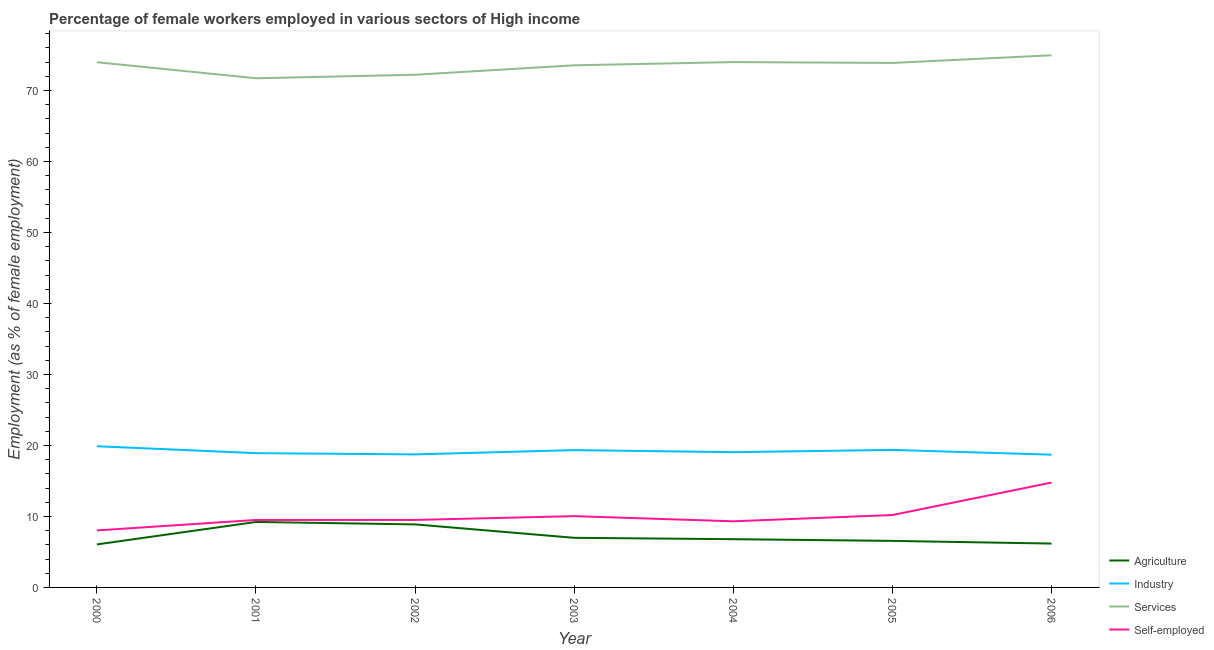Does the line corresponding to percentage of female workers in services intersect with the line corresponding to percentage of female workers in agriculture?
Provide a succinct answer. No. What is the percentage of female workers in services in 2004?
Your response must be concise. 74. Across all years, what is the maximum percentage of female workers in services?
Ensure brevity in your answer.  74.95. Across all years, what is the minimum percentage of self employed female workers?
Offer a terse response. 8.03. In which year was the percentage of self employed female workers maximum?
Provide a succinct answer. 2006. What is the total percentage of female workers in industry in the graph?
Ensure brevity in your answer.  134. What is the difference between the percentage of self employed female workers in 2001 and that in 2003?
Provide a short and direct response. -0.54. What is the difference between the percentage of female workers in agriculture in 2006 and the percentage of female workers in services in 2003?
Keep it short and to the point. -67.36. What is the average percentage of self employed female workers per year?
Your response must be concise. 10.19. In the year 2005, what is the difference between the percentage of female workers in agriculture and percentage of female workers in services?
Offer a terse response. -67.32. What is the ratio of the percentage of female workers in services in 2001 to that in 2004?
Provide a succinct answer. 0.97. What is the difference between the highest and the second highest percentage of self employed female workers?
Your answer should be compact. 4.57. What is the difference between the highest and the lowest percentage of female workers in services?
Make the answer very short. 3.24. In how many years, is the percentage of female workers in industry greater than the average percentage of female workers in industry taken over all years?
Your response must be concise. 3. Is the sum of the percentage of female workers in industry in 2002 and 2004 greater than the maximum percentage of female workers in services across all years?
Your answer should be very brief. No. Is it the case that in every year, the sum of the percentage of self employed female workers and percentage of female workers in industry is greater than the sum of percentage of female workers in agriculture and percentage of female workers in services?
Make the answer very short. No. Is it the case that in every year, the sum of the percentage of female workers in agriculture and percentage of female workers in industry is greater than the percentage of female workers in services?
Offer a very short reply. No. Is the percentage of self employed female workers strictly greater than the percentage of female workers in industry over the years?
Your response must be concise. No. Is the percentage of female workers in agriculture strictly less than the percentage of female workers in industry over the years?
Provide a short and direct response. Yes. What is the difference between two consecutive major ticks on the Y-axis?
Keep it short and to the point. 10. Does the graph contain any zero values?
Offer a terse response. No. Where does the legend appear in the graph?
Provide a short and direct response. Bottom right. What is the title of the graph?
Ensure brevity in your answer.  Percentage of female workers employed in various sectors of High income. Does "Corruption" appear as one of the legend labels in the graph?
Give a very brief answer. No. What is the label or title of the X-axis?
Offer a very short reply. Year. What is the label or title of the Y-axis?
Provide a short and direct response. Employment (as % of female employment). What is the Employment (as % of female employment) of Agriculture in 2000?
Ensure brevity in your answer.  6.06. What is the Employment (as % of female employment) of Industry in 2000?
Provide a succinct answer. 19.89. What is the Employment (as % of female employment) of Services in 2000?
Your response must be concise. 73.98. What is the Employment (as % of female employment) in Self-employed in 2000?
Your response must be concise. 8.03. What is the Employment (as % of female employment) of Agriculture in 2001?
Give a very brief answer. 9.22. What is the Employment (as % of female employment) of Industry in 2001?
Offer a very short reply. 18.91. What is the Employment (as % of female employment) of Services in 2001?
Your response must be concise. 71.72. What is the Employment (as % of female employment) of Self-employed in 2001?
Give a very brief answer. 9.5. What is the Employment (as % of female employment) of Agriculture in 2002?
Keep it short and to the point. 8.88. What is the Employment (as % of female employment) of Industry in 2002?
Offer a very short reply. 18.74. What is the Employment (as % of female employment) of Services in 2002?
Your response must be concise. 72.21. What is the Employment (as % of female employment) of Self-employed in 2002?
Make the answer very short. 9.51. What is the Employment (as % of female employment) of Agriculture in 2003?
Your answer should be compact. 6.99. What is the Employment (as % of female employment) in Industry in 2003?
Your response must be concise. 19.34. What is the Employment (as % of female employment) of Services in 2003?
Give a very brief answer. 73.54. What is the Employment (as % of female employment) in Self-employed in 2003?
Provide a succinct answer. 10.04. What is the Employment (as % of female employment) in Agriculture in 2004?
Your response must be concise. 6.8. What is the Employment (as % of female employment) of Industry in 2004?
Your response must be concise. 19.05. What is the Employment (as % of female employment) in Services in 2004?
Make the answer very short. 74. What is the Employment (as % of female employment) of Self-employed in 2004?
Offer a very short reply. 9.31. What is the Employment (as % of female employment) of Agriculture in 2005?
Ensure brevity in your answer.  6.55. What is the Employment (as % of female employment) of Industry in 2005?
Offer a terse response. 19.37. What is the Employment (as % of female employment) of Services in 2005?
Your answer should be compact. 73.87. What is the Employment (as % of female employment) of Self-employed in 2005?
Your answer should be compact. 10.2. What is the Employment (as % of female employment) in Agriculture in 2006?
Make the answer very short. 6.18. What is the Employment (as % of female employment) of Industry in 2006?
Provide a succinct answer. 18.7. What is the Employment (as % of female employment) of Services in 2006?
Provide a short and direct response. 74.95. What is the Employment (as % of female employment) of Self-employed in 2006?
Offer a very short reply. 14.77. Across all years, what is the maximum Employment (as % of female employment) of Agriculture?
Keep it short and to the point. 9.22. Across all years, what is the maximum Employment (as % of female employment) of Industry?
Provide a succinct answer. 19.89. Across all years, what is the maximum Employment (as % of female employment) in Services?
Keep it short and to the point. 74.95. Across all years, what is the maximum Employment (as % of female employment) of Self-employed?
Your answer should be very brief. 14.77. Across all years, what is the minimum Employment (as % of female employment) of Agriculture?
Give a very brief answer. 6.06. Across all years, what is the minimum Employment (as % of female employment) of Industry?
Provide a succinct answer. 18.7. Across all years, what is the minimum Employment (as % of female employment) in Services?
Your response must be concise. 71.72. Across all years, what is the minimum Employment (as % of female employment) of Self-employed?
Offer a very short reply. 8.03. What is the total Employment (as % of female employment) in Agriculture in the graph?
Give a very brief answer. 50.67. What is the total Employment (as % of female employment) in Industry in the graph?
Offer a terse response. 134. What is the total Employment (as % of female employment) in Services in the graph?
Offer a terse response. 514.27. What is the total Employment (as % of female employment) in Self-employed in the graph?
Your answer should be very brief. 71.36. What is the difference between the Employment (as % of female employment) in Agriculture in 2000 and that in 2001?
Your answer should be compact. -3.16. What is the difference between the Employment (as % of female employment) of Industry in 2000 and that in 2001?
Offer a terse response. 0.97. What is the difference between the Employment (as % of female employment) of Services in 2000 and that in 2001?
Keep it short and to the point. 2.26. What is the difference between the Employment (as % of female employment) in Self-employed in 2000 and that in 2001?
Your answer should be compact. -1.48. What is the difference between the Employment (as % of female employment) in Agriculture in 2000 and that in 2002?
Provide a short and direct response. -2.82. What is the difference between the Employment (as % of female employment) in Industry in 2000 and that in 2002?
Give a very brief answer. 1.15. What is the difference between the Employment (as % of female employment) of Services in 2000 and that in 2002?
Make the answer very short. 1.77. What is the difference between the Employment (as % of female employment) of Self-employed in 2000 and that in 2002?
Offer a terse response. -1.48. What is the difference between the Employment (as % of female employment) of Agriculture in 2000 and that in 2003?
Your response must be concise. -0.93. What is the difference between the Employment (as % of female employment) in Industry in 2000 and that in 2003?
Make the answer very short. 0.55. What is the difference between the Employment (as % of female employment) in Services in 2000 and that in 2003?
Make the answer very short. 0.44. What is the difference between the Employment (as % of female employment) of Self-employed in 2000 and that in 2003?
Provide a short and direct response. -2.02. What is the difference between the Employment (as % of female employment) in Agriculture in 2000 and that in 2004?
Your answer should be compact. -0.74. What is the difference between the Employment (as % of female employment) of Industry in 2000 and that in 2004?
Your answer should be compact. 0.83. What is the difference between the Employment (as % of female employment) of Services in 2000 and that in 2004?
Your answer should be compact. -0.02. What is the difference between the Employment (as % of female employment) of Self-employed in 2000 and that in 2004?
Provide a short and direct response. -1.29. What is the difference between the Employment (as % of female employment) of Agriculture in 2000 and that in 2005?
Ensure brevity in your answer.  -0.5. What is the difference between the Employment (as % of female employment) of Industry in 2000 and that in 2005?
Offer a very short reply. 0.52. What is the difference between the Employment (as % of female employment) of Services in 2000 and that in 2005?
Provide a short and direct response. 0.1. What is the difference between the Employment (as % of female employment) in Self-employed in 2000 and that in 2005?
Make the answer very short. -2.17. What is the difference between the Employment (as % of female employment) of Agriculture in 2000 and that in 2006?
Offer a terse response. -0.12. What is the difference between the Employment (as % of female employment) of Industry in 2000 and that in 2006?
Offer a very short reply. 1.19. What is the difference between the Employment (as % of female employment) of Services in 2000 and that in 2006?
Offer a very short reply. -0.97. What is the difference between the Employment (as % of female employment) in Self-employed in 2000 and that in 2006?
Provide a short and direct response. -6.75. What is the difference between the Employment (as % of female employment) in Agriculture in 2001 and that in 2002?
Your answer should be very brief. 0.34. What is the difference between the Employment (as % of female employment) in Industry in 2001 and that in 2002?
Your answer should be compact. 0.18. What is the difference between the Employment (as % of female employment) of Services in 2001 and that in 2002?
Offer a very short reply. -0.49. What is the difference between the Employment (as % of female employment) in Self-employed in 2001 and that in 2002?
Ensure brevity in your answer.  -0. What is the difference between the Employment (as % of female employment) in Agriculture in 2001 and that in 2003?
Your response must be concise. 2.23. What is the difference between the Employment (as % of female employment) of Industry in 2001 and that in 2003?
Your response must be concise. -0.43. What is the difference between the Employment (as % of female employment) in Services in 2001 and that in 2003?
Provide a succinct answer. -1.82. What is the difference between the Employment (as % of female employment) of Self-employed in 2001 and that in 2003?
Ensure brevity in your answer.  -0.54. What is the difference between the Employment (as % of female employment) of Agriculture in 2001 and that in 2004?
Keep it short and to the point. 2.43. What is the difference between the Employment (as % of female employment) of Industry in 2001 and that in 2004?
Offer a very short reply. -0.14. What is the difference between the Employment (as % of female employment) in Services in 2001 and that in 2004?
Offer a terse response. -2.28. What is the difference between the Employment (as % of female employment) of Self-employed in 2001 and that in 2004?
Provide a short and direct response. 0.19. What is the difference between the Employment (as % of female employment) in Agriculture in 2001 and that in 2005?
Offer a very short reply. 2.67. What is the difference between the Employment (as % of female employment) of Industry in 2001 and that in 2005?
Provide a succinct answer. -0.46. What is the difference between the Employment (as % of female employment) of Services in 2001 and that in 2005?
Provide a short and direct response. -2.16. What is the difference between the Employment (as % of female employment) of Self-employed in 2001 and that in 2005?
Your response must be concise. -0.69. What is the difference between the Employment (as % of female employment) of Agriculture in 2001 and that in 2006?
Provide a succinct answer. 3.04. What is the difference between the Employment (as % of female employment) in Industry in 2001 and that in 2006?
Provide a short and direct response. 0.22. What is the difference between the Employment (as % of female employment) of Services in 2001 and that in 2006?
Ensure brevity in your answer.  -3.24. What is the difference between the Employment (as % of female employment) of Self-employed in 2001 and that in 2006?
Offer a very short reply. -5.27. What is the difference between the Employment (as % of female employment) in Agriculture in 2002 and that in 2003?
Ensure brevity in your answer.  1.89. What is the difference between the Employment (as % of female employment) of Industry in 2002 and that in 2003?
Provide a short and direct response. -0.6. What is the difference between the Employment (as % of female employment) in Services in 2002 and that in 2003?
Your answer should be compact. -1.33. What is the difference between the Employment (as % of female employment) of Self-employed in 2002 and that in 2003?
Provide a short and direct response. -0.54. What is the difference between the Employment (as % of female employment) in Agriculture in 2002 and that in 2004?
Keep it short and to the point. 2.08. What is the difference between the Employment (as % of female employment) in Industry in 2002 and that in 2004?
Offer a terse response. -0.31. What is the difference between the Employment (as % of female employment) in Services in 2002 and that in 2004?
Give a very brief answer. -1.79. What is the difference between the Employment (as % of female employment) of Self-employed in 2002 and that in 2004?
Your answer should be compact. 0.19. What is the difference between the Employment (as % of female employment) in Agriculture in 2002 and that in 2005?
Make the answer very short. 2.32. What is the difference between the Employment (as % of female employment) in Industry in 2002 and that in 2005?
Offer a very short reply. -0.63. What is the difference between the Employment (as % of female employment) in Services in 2002 and that in 2005?
Your answer should be compact. -1.67. What is the difference between the Employment (as % of female employment) in Self-employed in 2002 and that in 2005?
Your answer should be compact. -0.69. What is the difference between the Employment (as % of female employment) in Agriculture in 2002 and that in 2006?
Your answer should be very brief. 2.7. What is the difference between the Employment (as % of female employment) in Industry in 2002 and that in 2006?
Keep it short and to the point. 0.04. What is the difference between the Employment (as % of female employment) in Services in 2002 and that in 2006?
Keep it short and to the point. -2.74. What is the difference between the Employment (as % of female employment) in Self-employed in 2002 and that in 2006?
Ensure brevity in your answer.  -5.26. What is the difference between the Employment (as % of female employment) of Agriculture in 2003 and that in 2004?
Make the answer very short. 0.19. What is the difference between the Employment (as % of female employment) in Industry in 2003 and that in 2004?
Your answer should be very brief. 0.29. What is the difference between the Employment (as % of female employment) in Services in 2003 and that in 2004?
Provide a short and direct response. -0.46. What is the difference between the Employment (as % of female employment) in Self-employed in 2003 and that in 2004?
Your answer should be compact. 0.73. What is the difference between the Employment (as % of female employment) of Agriculture in 2003 and that in 2005?
Make the answer very short. 0.43. What is the difference between the Employment (as % of female employment) of Industry in 2003 and that in 2005?
Offer a terse response. -0.03. What is the difference between the Employment (as % of female employment) in Services in 2003 and that in 2005?
Provide a succinct answer. -0.33. What is the difference between the Employment (as % of female employment) of Self-employed in 2003 and that in 2005?
Make the answer very short. -0.16. What is the difference between the Employment (as % of female employment) of Agriculture in 2003 and that in 2006?
Make the answer very short. 0.81. What is the difference between the Employment (as % of female employment) of Industry in 2003 and that in 2006?
Offer a terse response. 0.64. What is the difference between the Employment (as % of female employment) in Services in 2003 and that in 2006?
Keep it short and to the point. -1.41. What is the difference between the Employment (as % of female employment) of Self-employed in 2003 and that in 2006?
Ensure brevity in your answer.  -4.73. What is the difference between the Employment (as % of female employment) in Agriculture in 2004 and that in 2005?
Your answer should be very brief. 0.24. What is the difference between the Employment (as % of female employment) in Industry in 2004 and that in 2005?
Offer a very short reply. -0.32. What is the difference between the Employment (as % of female employment) of Services in 2004 and that in 2005?
Give a very brief answer. 0.12. What is the difference between the Employment (as % of female employment) in Self-employed in 2004 and that in 2005?
Offer a terse response. -0.88. What is the difference between the Employment (as % of female employment) of Agriculture in 2004 and that in 2006?
Provide a short and direct response. 0.62. What is the difference between the Employment (as % of female employment) of Industry in 2004 and that in 2006?
Ensure brevity in your answer.  0.35. What is the difference between the Employment (as % of female employment) of Services in 2004 and that in 2006?
Ensure brevity in your answer.  -0.96. What is the difference between the Employment (as % of female employment) in Self-employed in 2004 and that in 2006?
Your answer should be compact. -5.46. What is the difference between the Employment (as % of female employment) in Agriculture in 2005 and that in 2006?
Ensure brevity in your answer.  0.38. What is the difference between the Employment (as % of female employment) of Industry in 2005 and that in 2006?
Your answer should be compact. 0.67. What is the difference between the Employment (as % of female employment) in Services in 2005 and that in 2006?
Offer a terse response. -1.08. What is the difference between the Employment (as % of female employment) of Self-employed in 2005 and that in 2006?
Keep it short and to the point. -4.57. What is the difference between the Employment (as % of female employment) of Agriculture in 2000 and the Employment (as % of female employment) of Industry in 2001?
Your answer should be compact. -12.86. What is the difference between the Employment (as % of female employment) of Agriculture in 2000 and the Employment (as % of female employment) of Services in 2001?
Provide a succinct answer. -65.66. What is the difference between the Employment (as % of female employment) of Agriculture in 2000 and the Employment (as % of female employment) of Self-employed in 2001?
Provide a succinct answer. -3.45. What is the difference between the Employment (as % of female employment) of Industry in 2000 and the Employment (as % of female employment) of Services in 2001?
Provide a short and direct response. -51.83. What is the difference between the Employment (as % of female employment) of Industry in 2000 and the Employment (as % of female employment) of Self-employed in 2001?
Provide a succinct answer. 10.38. What is the difference between the Employment (as % of female employment) of Services in 2000 and the Employment (as % of female employment) of Self-employed in 2001?
Ensure brevity in your answer.  64.48. What is the difference between the Employment (as % of female employment) of Agriculture in 2000 and the Employment (as % of female employment) of Industry in 2002?
Give a very brief answer. -12.68. What is the difference between the Employment (as % of female employment) of Agriculture in 2000 and the Employment (as % of female employment) of Services in 2002?
Ensure brevity in your answer.  -66.15. What is the difference between the Employment (as % of female employment) in Agriculture in 2000 and the Employment (as % of female employment) in Self-employed in 2002?
Offer a very short reply. -3.45. What is the difference between the Employment (as % of female employment) of Industry in 2000 and the Employment (as % of female employment) of Services in 2002?
Give a very brief answer. -52.32. What is the difference between the Employment (as % of female employment) in Industry in 2000 and the Employment (as % of female employment) in Self-employed in 2002?
Keep it short and to the point. 10.38. What is the difference between the Employment (as % of female employment) in Services in 2000 and the Employment (as % of female employment) in Self-employed in 2002?
Your response must be concise. 64.47. What is the difference between the Employment (as % of female employment) of Agriculture in 2000 and the Employment (as % of female employment) of Industry in 2003?
Make the answer very short. -13.28. What is the difference between the Employment (as % of female employment) of Agriculture in 2000 and the Employment (as % of female employment) of Services in 2003?
Your response must be concise. -67.48. What is the difference between the Employment (as % of female employment) in Agriculture in 2000 and the Employment (as % of female employment) in Self-employed in 2003?
Offer a terse response. -3.98. What is the difference between the Employment (as % of female employment) of Industry in 2000 and the Employment (as % of female employment) of Services in 2003?
Ensure brevity in your answer.  -53.65. What is the difference between the Employment (as % of female employment) of Industry in 2000 and the Employment (as % of female employment) of Self-employed in 2003?
Offer a very short reply. 9.85. What is the difference between the Employment (as % of female employment) in Services in 2000 and the Employment (as % of female employment) in Self-employed in 2003?
Your response must be concise. 63.94. What is the difference between the Employment (as % of female employment) of Agriculture in 2000 and the Employment (as % of female employment) of Industry in 2004?
Offer a very short reply. -12.99. What is the difference between the Employment (as % of female employment) in Agriculture in 2000 and the Employment (as % of female employment) in Services in 2004?
Ensure brevity in your answer.  -67.94. What is the difference between the Employment (as % of female employment) in Agriculture in 2000 and the Employment (as % of female employment) in Self-employed in 2004?
Your answer should be very brief. -3.26. What is the difference between the Employment (as % of female employment) in Industry in 2000 and the Employment (as % of female employment) in Services in 2004?
Ensure brevity in your answer.  -54.11. What is the difference between the Employment (as % of female employment) in Industry in 2000 and the Employment (as % of female employment) in Self-employed in 2004?
Your answer should be very brief. 10.57. What is the difference between the Employment (as % of female employment) in Services in 2000 and the Employment (as % of female employment) in Self-employed in 2004?
Your response must be concise. 64.66. What is the difference between the Employment (as % of female employment) in Agriculture in 2000 and the Employment (as % of female employment) in Industry in 2005?
Your response must be concise. -13.31. What is the difference between the Employment (as % of female employment) of Agriculture in 2000 and the Employment (as % of female employment) of Services in 2005?
Provide a short and direct response. -67.82. What is the difference between the Employment (as % of female employment) of Agriculture in 2000 and the Employment (as % of female employment) of Self-employed in 2005?
Offer a terse response. -4.14. What is the difference between the Employment (as % of female employment) in Industry in 2000 and the Employment (as % of female employment) in Services in 2005?
Provide a succinct answer. -53.99. What is the difference between the Employment (as % of female employment) of Industry in 2000 and the Employment (as % of female employment) of Self-employed in 2005?
Offer a very short reply. 9.69. What is the difference between the Employment (as % of female employment) in Services in 2000 and the Employment (as % of female employment) in Self-employed in 2005?
Make the answer very short. 63.78. What is the difference between the Employment (as % of female employment) in Agriculture in 2000 and the Employment (as % of female employment) in Industry in 2006?
Make the answer very short. -12.64. What is the difference between the Employment (as % of female employment) in Agriculture in 2000 and the Employment (as % of female employment) in Services in 2006?
Ensure brevity in your answer.  -68.9. What is the difference between the Employment (as % of female employment) of Agriculture in 2000 and the Employment (as % of female employment) of Self-employed in 2006?
Provide a short and direct response. -8.71. What is the difference between the Employment (as % of female employment) in Industry in 2000 and the Employment (as % of female employment) in Services in 2006?
Offer a very short reply. -55.07. What is the difference between the Employment (as % of female employment) in Industry in 2000 and the Employment (as % of female employment) in Self-employed in 2006?
Ensure brevity in your answer.  5.12. What is the difference between the Employment (as % of female employment) in Services in 2000 and the Employment (as % of female employment) in Self-employed in 2006?
Provide a short and direct response. 59.21. What is the difference between the Employment (as % of female employment) in Agriculture in 2001 and the Employment (as % of female employment) in Industry in 2002?
Keep it short and to the point. -9.52. What is the difference between the Employment (as % of female employment) in Agriculture in 2001 and the Employment (as % of female employment) in Services in 2002?
Provide a short and direct response. -62.99. What is the difference between the Employment (as % of female employment) in Agriculture in 2001 and the Employment (as % of female employment) in Self-employed in 2002?
Ensure brevity in your answer.  -0.29. What is the difference between the Employment (as % of female employment) in Industry in 2001 and the Employment (as % of female employment) in Services in 2002?
Make the answer very short. -53.29. What is the difference between the Employment (as % of female employment) in Industry in 2001 and the Employment (as % of female employment) in Self-employed in 2002?
Keep it short and to the point. 9.41. What is the difference between the Employment (as % of female employment) of Services in 2001 and the Employment (as % of female employment) of Self-employed in 2002?
Ensure brevity in your answer.  62.21. What is the difference between the Employment (as % of female employment) in Agriculture in 2001 and the Employment (as % of female employment) in Industry in 2003?
Make the answer very short. -10.12. What is the difference between the Employment (as % of female employment) of Agriculture in 2001 and the Employment (as % of female employment) of Services in 2003?
Make the answer very short. -64.32. What is the difference between the Employment (as % of female employment) of Agriculture in 2001 and the Employment (as % of female employment) of Self-employed in 2003?
Make the answer very short. -0.82. What is the difference between the Employment (as % of female employment) in Industry in 2001 and the Employment (as % of female employment) in Services in 2003?
Give a very brief answer. -54.63. What is the difference between the Employment (as % of female employment) of Industry in 2001 and the Employment (as % of female employment) of Self-employed in 2003?
Make the answer very short. 8.87. What is the difference between the Employment (as % of female employment) in Services in 2001 and the Employment (as % of female employment) in Self-employed in 2003?
Your answer should be very brief. 61.68. What is the difference between the Employment (as % of female employment) of Agriculture in 2001 and the Employment (as % of female employment) of Industry in 2004?
Ensure brevity in your answer.  -9.83. What is the difference between the Employment (as % of female employment) of Agriculture in 2001 and the Employment (as % of female employment) of Services in 2004?
Ensure brevity in your answer.  -64.77. What is the difference between the Employment (as % of female employment) in Agriculture in 2001 and the Employment (as % of female employment) in Self-employed in 2004?
Keep it short and to the point. -0.09. What is the difference between the Employment (as % of female employment) in Industry in 2001 and the Employment (as % of female employment) in Services in 2004?
Provide a short and direct response. -55.08. What is the difference between the Employment (as % of female employment) in Industry in 2001 and the Employment (as % of female employment) in Self-employed in 2004?
Give a very brief answer. 9.6. What is the difference between the Employment (as % of female employment) in Services in 2001 and the Employment (as % of female employment) in Self-employed in 2004?
Offer a very short reply. 62.4. What is the difference between the Employment (as % of female employment) of Agriculture in 2001 and the Employment (as % of female employment) of Industry in 2005?
Offer a terse response. -10.15. What is the difference between the Employment (as % of female employment) in Agriculture in 2001 and the Employment (as % of female employment) in Services in 2005?
Your response must be concise. -64.65. What is the difference between the Employment (as % of female employment) in Agriculture in 2001 and the Employment (as % of female employment) in Self-employed in 2005?
Offer a terse response. -0.98. What is the difference between the Employment (as % of female employment) in Industry in 2001 and the Employment (as % of female employment) in Services in 2005?
Provide a short and direct response. -54.96. What is the difference between the Employment (as % of female employment) in Industry in 2001 and the Employment (as % of female employment) in Self-employed in 2005?
Ensure brevity in your answer.  8.72. What is the difference between the Employment (as % of female employment) of Services in 2001 and the Employment (as % of female employment) of Self-employed in 2005?
Make the answer very short. 61.52. What is the difference between the Employment (as % of female employment) in Agriculture in 2001 and the Employment (as % of female employment) in Industry in 2006?
Keep it short and to the point. -9.48. What is the difference between the Employment (as % of female employment) in Agriculture in 2001 and the Employment (as % of female employment) in Services in 2006?
Provide a succinct answer. -65.73. What is the difference between the Employment (as % of female employment) of Agriculture in 2001 and the Employment (as % of female employment) of Self-employed in 2006?
Your answer should be compact. -5.55. What is the difference between the Employment (as % of female employment) of Industry in 2001 and the Employment (as % of female employment) of Services in 2006?
Your answer should be very brief. -56.04. What is the difference between the Employment (as % of female employment) of Industry in 2001 and the Employment (as % of female employment) of Self-employed in 2006?
Offer a terse response. 4.14. What is the difference between the Employment (as % of female employment) in Services in 2001 and the Employment (as % of female employment) in Self-employed in 2006?
Offer a terse response. 56.95. What is the difference between the Employment (as % of female employment) in Agriculture in 2002 and the Employment (as % of female employment) in Industry in 2003?
Your response must be concise. -10.46. What is the difference between the Employment (as % of female employment) of Agriculture in 2002 and the Employment (as % of female employment) of Services in 2003?
Make the answer very short. -64.66. What is the difference between the Employment (as % of female employment) of Agriculture in 2002 and the Employment (as % of female employment) of Self-employed in 2003?
Your response must be concise. -1.16. What is the difference between the Employment (as % of female employment) of Industry in 2002 and the Employment (as % of female employment) of Services in 2003?
Give a very brief answer. -54.8. What is the difference between the Employment (as % of female employment) of Industry in 2002 and the Employment (as % of female employment) of Self-employed in 2003?
Your answer should be compact. 8.7. What is the difference between the Employment (as % of female employment) in Services in 2002 and the Employment (as % of female employment) in Self-employed in 2003?
Your response must be concise. 62.17. What is the difference between the Employment (as % of female employment) in Agriculture in 2002 and the Employment (as % of female employment) in Industry in 2004?
Offer a very short reply. -10.17. What is the difference between the Employment (as % of female employment) of Agriculture in 2002 and the Employment (as % of female employment) of Services in 2004?
Offer a very short reply. -65.12. What is the difference between the Employment (as % of female employment) in Agriculture in 2002 and the Employment (as % of female employment) in Self-employed in 2004?
Offer a very short reply. -0.44. What is the difference between the Employment (as % of female employment) of Industry in 2002 and the Employment (as % of female employment) of Services in 2004?
Offer a terse response. -55.26. What is the difference between the Employment (as % of female employment) of Industry in 2002 and the Employment (as % of female employment) of Self-employed in 2004?
Your answer should be compact. 9.42. What is the difference between the Employment (as % of female employment) of Services in 2002 and the Employment (as % of female employment) of Self-employed in 2004?
Offer a terse response. 62.89. What is the difference between the Employment (as % of female employment) of Agriculture in 2002 and the Employment (as % of female employment) of Industry in 2005?
Offer a terse response. -10.49. What is the difference between the Employment (as % of female employment) in Agriculture in 2002 and the Employment (as % of female employment) in Services in 2005?
Provide a succinct answer. -65. What is the difference between the Employment (as % of female employment) in Agriculture in 2002 and the Employment (as % of female employment) in Self-employed in 2005?
Keep it short and to the point. -1.32. What is the difference between the Employment (as % of female employment) in Industry in 2002 and the Employment (as % of female employment) in Services in 2005?
Provide a succinct answer. -55.14. What is the difference between the Employment (as % of female employment) in Industry in 2002 and the Employment (as % of female employment) in Self-employed in 2005?
Offer a terse response. 8.54. What is the difference between the Employment (as % of female employment) of Services in 2002 and the Employment (as % of female employment) of Self-employed in 2005?
Offer a very short reply. 62.01. What is the difference between the Employment (as % of female employment) in Agriculture in 2002 and the Employment (as % of female employment) in Industry in 2006?
Your answer should be very brief. -9.82. What is the difference between the Employment (as % of female employment) of Agriculture in 2002 and the Employment (as % of female employment) of Services in 2006?
Offer a terse response. -66.07. What is the difference between the Employment (as % of female employment) in Agriculture in 2002 and the Employment (as % of female employment) in Self-employed in 2006?
Make the answer very short. -5.89. What is the difference between the Employment (as % of female employment) in Industry in 2002 and the Employment (as % of female employment) in Services in 2006?
Your answer should be compact. -56.21. What is the difference between the Employment (as % of female employment) in Industry in 2002 and the Employment (as % of female employment) in Self-employed in 2006?
Make the answer very short. 3.97. What is the difference between the Employment (as % of female employment) of Services in 2002 and the Employment (as % of female employment) of Self-employed in 2006?
Provide a short and direct response. 57.44. What is the difference between the Employment (as % of female employment) of Agriculture in 2003 and the Employment (as % of female employment) of Industry in 2004?
Your answer should be compact. -12.06. What is the difference between the Employment (as % of female employment) in Agriculture in 2003 and the Employment (as % of female employment) in Services in 2004?
Your answer should be very brief. -67.01. What is the difference between the Employment (as % of female employment) in Agriculture in 2003 and the Employment (as % of female employment) in Self-employed in 2004?
Offer a very short reply. -2.33. What is the difference between the Employment (as % of female employment) in Industry in 2003 and the Employment (as % of female employment) in Services in 2004?
Provide a short and direct response. -54.65. What is the difference between the Employment (as % of female employment) of Industry in 2003 and the Employment (as % of female employment) of Self-employed in 2004?
Keep it short and to the point. 10.03. What is the difference between the Employment (as % of female employment) of Services in 2003 and the Employment (as % of female employment) of Self-employed in 2004?
Offer a terse response. 64.23. What is the difference between the Employment (as % of female employment) in Agriculture in 2003 and the Employment (as % of female employment) in Industry in 2005?
Ensure brevity in your answer.  -12.38. What is the difference between the Employment (as % of female employment) in Agriculture in 2003 and the Employment (as % of female employment) in Services in 2005?
Ensure brevity in your answer.  -66.89. What is the difference between the Employment (as % of female employment) in Agriculture in 2003 and the Employment (as % of female employment) in Self-employed in 2005?
Ensure brevity in your answer.  -3.21. What is the difference between the Employment (as % of female employment) in Industry in 2003 and the Employment (as % of female employment) in Services in 2005?
Provide a succinct answer. -54.53. What is the difference between the Employment (as % of female employment) in Industry in 2003 and the Employment (as % of female employment) in Self-employed in 2005?
Give a very brief answer. 9.14. What is the difference between the Employment (as % of female employment) in Services in 2003 and the Employment (as % of female employment) in Self-employed in 2005?
Your answer should be compact. 63.34. What is the difference between the Employment (as % of female employment) of Agriculture in 2003 and the Employment (as % of female employment) of Industry in 2006?
Offer a very short reply. -11.71. What is the difference between the Employment (as % of female employment) in Agriculture in 2003 and the Employment (as % of female employment) in Services in 2006?
Offer a very short reply. -67.96. What is the difference between the Employment (as % of female employment) of Agriculture in 2003 and the Employment (as % of female employment) of Self-employed in 2006?
Make the answer very short. -7.78. What is the difference between the Employment (as % of female employment) in Industry in 2003 and the Employment (as % of female employment) in Services in 2006?
Keep it short and to the point. -55.61. What is the difference between the Employment (as % of female employment) in Industry in 2003 and the Employment (as % of female employment) in Self-employed in 2006?
Keep it short and to the point. 4.57. What is the difference between the Employment (as % of female employment) of Services in 2003 and the Employment (as % of female employment) of Self-employed in 2006?
Keep it short and to the point. 58.77. What is the difference between the Employment (as % of female employment) of Agriculture in 2004 and the Employment (as % of female employment) of Industry in 2005?
Ensure brevity in your answer.  -12.58. What is the difference between the Employment (as % of female employment) of Agriculture in 2004 and the Employment (as % of female employment) of Services in 2005?
Your response must be concise. -67.08. What is the difference between the Employment (as % of female employment) of Agriculture in 2004 and the Employment (as % of female employment) of Self-employed in 2005?
Your answer should be compact. -3.4. What is the difference between the Employment (as % of female employment) of Industry in 2004 and the Employment (as % of female employment) of Services in 2005?
Your answer should be very brief. -54.82. What is the difference between the Employment (as % of female employment) in Industry in 2004 and the Employment (as % of female employment) in Self-employed in 2005?
Ensure brevity in your answer.  8.85. What is the difference between the Employment (as % of female employment) in Services in 2004 and the Employment (as % of female employment) in Self-employed in 2005?
Keep it short and to the point. 63.8. What is the difference between the Employment (as % of female employment) in Agriculture in 2004 and the Employment (as % of female employment) in Industry in 2006?
Your answer should be very brief. -11.9. What is the difference between the Employment (as % of female employment) in Agriculture in 2004 and the Employment (as % of female employment) in Services in 2006?
Make the answer very short. -68.16. What is the difference between the Employment (as % of female employment) in Agriculture in 2004 and the Employment (as % of female employment) in Self-employed in 2006?
Your answer should be very brief. -7.98. What is the difference between the Employment (as % of female employment) of Industry in 2004 and the Employment (as % of female employment) of Services in 2006?
Make the answer very short. -55.9. What is the difference between the Employment (as % of female employment) in Industry in 2004 and the Employment (as % of female employment) in Self-employed in 2006?
Your answer should be very brief. 4.28. What is the difference between the Employment (as % of female employment) of Services in 2004 and the Employment (as % of female employment) of Self-employed in 2006?
Give a very brief answer. 59.22. What is the difference between the Employment (as % of female employment) in Agriculture in 2005 and the Employment (as % of female employment) in Industry in 2006?
Provide a succinct answer. -12.14. What is the difference between the Employment (as % of female employment) in Agriculture in 2005 and the Employment (as % of female employment) in Services in 2006?
Provide a short and direct response. -68.4. What is the difference between the Employment (as % of female employment) of Agriculture in 2005 and the Employment (as % of female employment) of Self-employed in 2006?
Your answer should be compact. -8.22. What is the difference between the Employment (as % of female employment) of Industry in 2005 and the Employment (as % of female employment) of Services in 2006?
Make the answer very short. -55.58. What is the difference between the Employment (as % of female employment) in Services in 2005 and the Employment (as % of female employment) in Self-employed in 2006?
Provide a succinct answer. 59.1. What is the average Employment (as % of female employment) of Agriculture per year?
Keep it short and to the point. 7.24. What is the average Employment (as % of female employment) of Industry per year?
Make the answer very short. 19.14. What is the average Employment (as % of female employment) of Services per year?
Give a very brief answer. 73.47. What is the average Employment (as % of female employment) of Self-employed per year?
Provide a succinct answer. 10.19. In the year 2000, what is the difference between the Employment (as % of female employment) of Agriculture and Employment (as % of female employment) of Industry?
Make the answer very short. -13.83. In the year 2000, what is the difference between the Employment (as % of female employment) of Agriculture and Employment (as % of female employment) of Services?
Keep it short and to the point. -67.92. In the year 2000, what is the difference between the Employment (as % of female employment) of Agriculture and Employment (as % of female employment) of Self-employed?
Your answer should be very brief. -1.97. In the year 2000, what is the difference between the Employment (as % of female employment) of Industry and Employment (as % of female employment) of Services?
Your response must be concise. -54.09. In the year 2000, what is the difference between the Employment (as % of female employment) of Industry and Employment (as % of female employment) of Self-employed?
Your answer should be compact. 11.86. In the year 2000, what is the difference between the Employment (as % of female employment) in Services and Employment (as % of female employment) in Self-employed?
Offer a very short reply. 65.95. In the year 2001, what is the difference between the Employment (as % of female employment) of Agriculture and Employment (as % of female employment) of Industry?
Provide a succinct answer. -9.69. In the year 2001, what is the difference between the Employment (as % of female employment) in Agriculture and Employment (as % of female employment) in Services?
Your answer should be very brief. -62.5. In the year 2001, what is the difference between the Employment (as % of female employment) of Agriculture and Employment (as % of female employment) of Self-employed?
Make the answer very short. -0.28. In the year 2001, what is the difference between the Employment (as % of female employment) of Industry and Employment (as % of female employment) of Services?
Provide a short and direct response. -52.8. In the year 2001, what is the difference between the Employment (as % of female employment) in Industry and Employment (as % of female employment) in Self-employed?
Give a very brief answer. 9.41. In the year 2001, what is the difference between the Employment (as % of female employment) of Services and Employment (as % of female employment) of Self-employed?
Offer a terse response. 62.21. In the year 2002, what is the difference between the Employment (as % of female employment) of Agriculture and Employment (as % of female employment) of Industry?
Your answer should be compact. -9.86. In the year 2002, what is the difference between the Employment (as % of female employment) of Agriculture and Employment (as % of female employment) of Services?
Provide a short and direct response. -63.33. In the year 2002, what is the difference between the Employment (as % of female employment) of Agriculture and Employment (as % of female employment) of Self-employed?
Offer a terse response. -0.63. In the year 2002, what is the difference between the Employment (as % of female employment) in Industry and Employment (as % of female employment) in Services?
Ensure brevity in your answer.  -53.47. In the year 2002, what is the difference between the Employment (as % of female employment) in Industry and Employment (as % of female employment) in Self-employed?
Your answer should be compact. 9.23. In the year 2002, what is the difference between the Employment (as % of female employment) of Services and Employment (as % of female employment) of Self-employed?
Provide a short and direct response. 62.7. In the year 2003, what is the difference between the Employment (as % of female employment) in Agriculture and Employment (as % of female employment) in Industry?
Provide a succinct answer. -12.35. In the year 2003, what is the difference between the Employment (as % of female employment) in Agriculture and Employment (as % of female employment) in Services?
Your response must be concise. -66.55. In the year 2003, what is the difference between the Employment (as % of female employment) of Agriculture and Employment (as % of female employment) of Self-employed?
Your answer should be very brief. -3.05. In the year 2003, what is the difference between the Employment (as % of female employment) of Industry and Employment (as % of female employment) of Services?
Give a very brief answer. -54.2. In the year 2003, what is the difference between the Employment (as % of female employment) in Industry and Employment (as % of female employment) in Self-employed?
Give a very brief answer. 9.3. In the year 2003, what is the difference between the Employment (as % of female employment) in Services and Employment (as % of female employment) in Self-employed?
Keep it short and to the point. 63.5. In the year 2004, what is the difference between the Employment (as % of female employment) of Agriculture and Employment (as % of female employment) of Industry?
Provide a short and direct response. -12.26. In the year 2004, what is the difference between the Employment (as % of female employment) in Agriculture and Employment (as % of female employment) in Services?
Give a very brief answer. -67.2. In the year 2004, what is the difference between the Employment (as % of female employment) of Agriculture and Employment (as % of female employment) of Self-employed?
Ensure brevity in your answer.  -2.52. In the year 2004, what is the difference between the Employment (as % of female employment) of Industry and Employment (as % of female employment) of Services?
Provide a short and direct response. -54.94. In the year 2004, what is the difference between the Employment (as % of female employment) in Industry and Employment (as % of female employment) in Self-employed?
Ensure brevity in your answer.  9.74. In the year 2004, what is the difference between the Employment (as % of female employment) in Services and Employment (as % of female employment) in Self-employed?
Your answer should be compact. 64.68. In the year 2005, what is the difference between the Employment (as % of female employment) of Agriculture and Employment (as % of female employment) of Industry?
Your answer should be compact. -12.82. In the year 2005, what is the difference between the Employment (as % of female employment) of Agriculture and Employment (as % of female employment) of Services?
Provide a succinct answer. -67.32. In the year 2005, what is the difference between the Employment (as % of female employment) of Agriculture and Employment (as % of female employment) of Self-employed?
Provide a succinct answer. -3.64. In the year 2005, what is the difference between the Employment (as % of female employment) of Industry and Employment (as % of female employment) of Services?
Your response must be concise. -54.5. In the year 2005, what is the difference between the Employment (as % of female employment) in Industry and Employment (as % of female employment) in Self-employed?
Ensure brevity in your answer.  9.17. In the year 2005, what is the difference between the Employment (as % of female employment) of Services and Employment (as % of female employment) of Self-employed?
Provide a succinct answer. 63.68. In the year 2006, what is the difference between the Employment (as % of female employment) in Agriculture and Employment (as % of female employment) in Industry?
Offer a very short reply. -12.52. In the year 2006, what is the difference between the Employment (as % of female employment) of Agriculture and Employment (as % of female employment) of Services?
Keep it short and to the point. -68.78. In the year 2006, what is the difference between the Employment (as % of female employment) of Agriculture and Employment (as % of female employment) of Self-employed?
Ensure brevity in your answer.  -8.59. In the year 2006, what is the difference between the Employment (as % of female employment) in Industry and Employment (as % of female employment) in Services?
Provide a short and direct response. -56.26. In the year 2006, what is the difference between the Employment (as % of female employment) in Industry and Employment (as % of female employment) in Self-employed?
Your answer should be very brief. 3.93. In the year 2006, what is the difference between the Employment (as % of female employment) in Services and Employment (as % of female employment) in Self-employed?
Your answer should be very brief. 60.18. What is the ratio of the Employment (as % of female employment) in Agriculture in 2000 to that in 2001?
Your response must be concise. 0.66. What is the ratio of the Employment (as % of female employment) of Industry in 2000 to that in 2001?
Keep it short and to the point. 1.05. What is the ratio of the Employment (as % of female employment) in Services in 2000 to that in 2001?
Your answer should be very brief. 1.03. What is the ratio of the Employment (as % of female employment) of Self-employed in 2000 to that in 2001?
Your response must be concise. 0.84. What is the ratio of the Employment (as % of female employment) of Agriculture in 2000 to that in 2002?
Provide a succinct answer. 0.68. What is the ratio of the Employment (as % of female employment) in Industry in 2000 to that in 2002?
Offer a terse response. 1.06. What is the ratio of the Employment (as % of female employment) in Services in 2000 to that in 2002?
Offer a terse response. 1.02. What is the ratio of the Employment (as % of female employment) of Self-employed in 2000 to that in 2002?
Your response must be concise. 0.84. What is the ratio of the Employment (as % of female employment) in Agriculture in 2000 to that in 2003?
Keep it short and to the point. 0.87. What is the ratio of the Employment (as % of female employment) of Industry in 2000 to that in 2003?
Your answer should be compact. 1.03. What is the ratio of the Employment (as % of female employment) of Services in 2000 to that in 2003?
Give a very brief answer. 1.01. What is the ratio of the Employment (as % of female employment) in Self-employed in 2000 to that in 2003?
Make the answer very short. 0.8. What is the ratio of the Employment (as % of female employment) of Agriculture in 2000 to that in 2004?
Give a very brief answer. 0.89. What is the ratio of the Employment (as % of female employment) of Industry in 2000 to that in 2004?
Your answer should be very brief. 1.04. What is the ratio of the Employment (as % of female employment) of Self-employed in 2000 to that in 2004?
Ensure brevity in your answer.  0.86. What is the ratio of the Employment (as % of female employment) in Agriculture in 2000 to that in 2005?
Your response must be concise. 0.92. What is the ratio of the Employment (as % of female employment) of Industry in 2000 to that in 2005?
Ensure brevity in your answer.  1.03. What is the ratio of the Employment (as % of female employment) in Services in 2000 to that in 2005?
Provide a short and direct response. 1. What is the ratio of the Employment (as % of female employment) in Self-employed in 2000 to that in 2005?
Provide a succinct answer. 0.79. What is the ratio of the Employment (as % of female employment) of Agriculture in 2000 to that in 2006?
Your answer should be very brief. 0.98. What is the ratio of the Employment (as % of female employment) in Industry in 2000 to that in 2006?
Provide a short and direct response. 1.06. What is the ratio of the Employment (as % of female employment) in Self-employed in 2000 to that in 2006?
Make the answer very short. 0.54. What is the ratio of the Employment (as % of female employment) of Agriculture in 2001 to that in 2002?
Offer a terse response. 1.04. What is the ratio of the Employment (as % of female employment) of Industry in 2001 to that in 2002?
Your answer should be very brief. 1.01. What is the ratio of the Employment (as % of female employment) in Self-employed in 2001 to that in 2002?
Make the answer very short. 1. What is the ratio of the Employment (as % of female employment) of Agriculture in 2001 to that in 2003?
Keep it short and to the point. 1.32. What is the ratio of the Employment (as % of female employment) of Industry in 2001 to that in 2003?
Offer a very short reply. 0.98. What is the ratio of the Employment (as % of female employment) of Services in 2001 to that in 2003?
Provide a short and direct response. 0.98. What is the ratio of the Employment (as % of female employment) of Self-employed in 2001 to that in 2003?
Give a very brief answer. 0.95. What is the ratio of the Employment (as % of female employment) in Agriculture in 2001 to that in 2004?
Ensure brevity in your answer.  1.36. What is the ratio of the Employment (as % of female employment) of Services in 2001 to that in 2004?
Offer a terse response. 0.97. What is the ratio of the Employment (as % of female employment) of Self-employed in 2001 to that in 2004?
Give a very brief answer. 1.02. What is the ratio of the Employment (as % of female employment) of Agriculture in 2001 to that in 2005?
Provide a short and direct response. 1.41. What is the ratio of the Employment (as % of female employment) of Industry in 2001 to that in 2005?
Ensure brevity in your answer.  0.98. What is the ratio of the Employment (as % of female employment) of Services in 2001 to that in 2005?
Give a very brief answer. 0.97. What is the ratio of the Employment (as % of female employment) of Self-employed in 2001 to that in 2005?
Offer a very short reply. 0.93. What is the ratio of the Employment (as % of female employment) of Agriculture in 2001 to that in 2006?
Your answer should be very brief. 1.49. What is the ratio of the Employment (as % of female employment) in Industry in 2001 to that in 2006?
Your answer should be very brief. 1.01. What is the ratio of the Employment (as % of female employment) of Services in 2001 to that in 2006?
Give a very brief answer. 0.96. What is the ratio of the Employment (as % of female employment) of Self-employed in 2001 to that in 2006?
Give a very brief answer. 0.64. What is the ratio of the Employment (as % of female employment) of Agriculture in 2002 to that in 2003?
Ensure brevity in your answer.  1.27. What is the ratio of the Employment (as % of female employment) of Industry in 2002 to that in 2003?
Offer a very short reply. 0.97. What is the ratio of the Employment (as % of female employment) of Services in 2002 to that in 2003?
Your answer should be very brief. 0.98. What is the ratio of the Employment (as % of female employment) in Self-employed in 2002 to that in 2003?
Make the answer very short. 0.95. What is the ratio of the Employment (as % of female employment) in Agriculture in 2002 to that in 2004?
Ensure brevity in your answer.  1.31. What is the ratio of the Employment (as % of female employment) of Industry in 2002 to that in 2004?
Give a very brief answer. 0.98. What is the ratio of the Employment (as % of female employment) in Services in 2002 to that in 2004?
Offer a terse response. 0.98. What is the ratio of the Employment (as % of female employment) of Self-employed in 2002 to that in 2004?
Provide a short and direct response. 1.02. What is the ratio of the Employment (as % of female employment) of Agriculture in 2002 to that in 2005?
Provide a succinct answer. 1.35. What is the ratio of the Employment (as % of female employment) of Industry in 2002 to that in 2005?
Offer a very short reply. 0.97. What is the ratio of the Employment (as % of female employment) in Services in 2002 to that in 2005?
Offer a terse response. 0.98. What is the ratio of the Employment (as % of female employment) of Self-employed in 2002 to that in 2005?
Make the answer very short. 0.93. What is the ratio of the Employment (as % of female employment) of Agriculture in 2002 to that in 2006?
Offer a very short reply. 1.44. What is the ratio of the Employment (as % of female employment) of Industry in 2002 to that in 2006?
Ensure brevity in your answer.  1. What is the ratio of the Employment (as % of female employment) in Services in 2002 to that in 2006?
Keep it short and to the point. 0.96. What is the ratio of the Employment (as % of female employment) in Self-employed in 2002 to that in 2006?
Your answer should be very brief. 0.64. What is the ratio of the Employment (as % of female employment) of Agriculture in 2003 to that in 2004?
Give a very brief answer. 1.03. What is the ratio of the Employment (as % of female employment) of Industry in 2003 to that in 2004?
Keep it short and to the point. 1.02. What is the ratio of the Employment (as % of female employment) in Services in 2003 to that in 2004?
Your answer should be compact. 0.99. What is the ratio of the Employment (as % of female employment) in Self-employed in 2003 to that in 2004?
Offer a terse response. 1.08. What is the ratio of the Employment (as % of female employment) in Agriculture in 2003 to that in 2005?
Provide a succinct answer. 1.07. What is the ratio of the Employment (as % of female employment) of Industry in 2003 to that in 2005?
Give a very brief answer. 1. What is the ratio of the Employment (as % of female employment) of Self-employed in 2003 to that in 2005?
Provide a short and direct response. 0.98. What is the ratio of the Employment (as % of female employment) in Agriculture in 2003 to that in 2006?
Give a very brief answer. 1.13. What is the ratio of the Employment (as % of female employment) of Industry in 2003 to that in 2006?
Your answer should be compact. 1.03. What is the ratio of the Employment (as % of female employment) in Services in 2003 to that in 2006?
Give a very brief answer. 0.98. What is the ratio of the Employment (as % of female employment) in Self-employed in 2003 to that in 2006?
Provide a short and direct response. 0.68. What is the ratio of the Employment (as % of female employment) in Agriculture in 2004 to that in 2005?
Provide a short and direct response. 1.04. What is the ratio of the Employment (as % of female employment) in Industry in 2004 to that in 2005?
Give a very brief answer. 0.98. What is the ratio of the Employment (as % of female employment) of Self-employed in 2004 to that in 2005?
Your response must be concise. 0.91. What is the ratio of the Employment (as % of female employment) in Industry in 2004 to that in 2006?
Give a very brief answer. 1.02. What is the ratio of the Employment (as % of female employment) in Services in 2004 to that in 2006?
Keep it short and to the point. 0.99. What is the ratio of the Employment (as % of female employment) of Self-employed in 2004 to that in 2006?
Your response must be concise. 0.63. What is the ratio of the Employment (as % of female employment) of Agriculture in 2005 to that in 2006?
Offer a very short reply. 1.06. What is the ratio of the Employment (as % of female employment) of Industry in 2005 to that in 2006?
Ensure brevity in your answer.  1.04. What is the ratio of the Employment (as % of female employment) of Services in 2005 to that in 2006?
Ensure brevity in your answer.  0.99. What is the ratio of the Employment (as % of female employment) of Self-employed in 2005 to that in 2006?
Make the answer very short. 0.69. What is the difference between the highest and the second highest Employment (as % of female employment) in Agriculture?
Give a very brief answer. 0.34. What is the difference between the highest and the second highest Employment (as % of female employment) in Industry?
Keep it short and to the point. 0.52. What is the difference between the highest and the second highest Employment (as % of female employment) in Services?
Provide a succinct answer. 0.96. What is the difference between the highest and the second highest Employment (as % of female employment) of Self-employed?
Your answer should be very brief. 4.57. What is the difference between the highest and the lowest Employment (as % of female employment) in Agriculture?
Provide a short and direct response. 3.16. What is the difference between the highest and the lowest Employment (as % of female employment) of Industry?
Provide a succinct answer. 1.19. What is the difference between the highest and the lowest Employment (as % of female employment) in Services?
Your response must be concise. 3.24. What is the difference between the highest and the lowest Employment (as % of female employment) in Self-employed?
Your response must be concise. 6.75. 